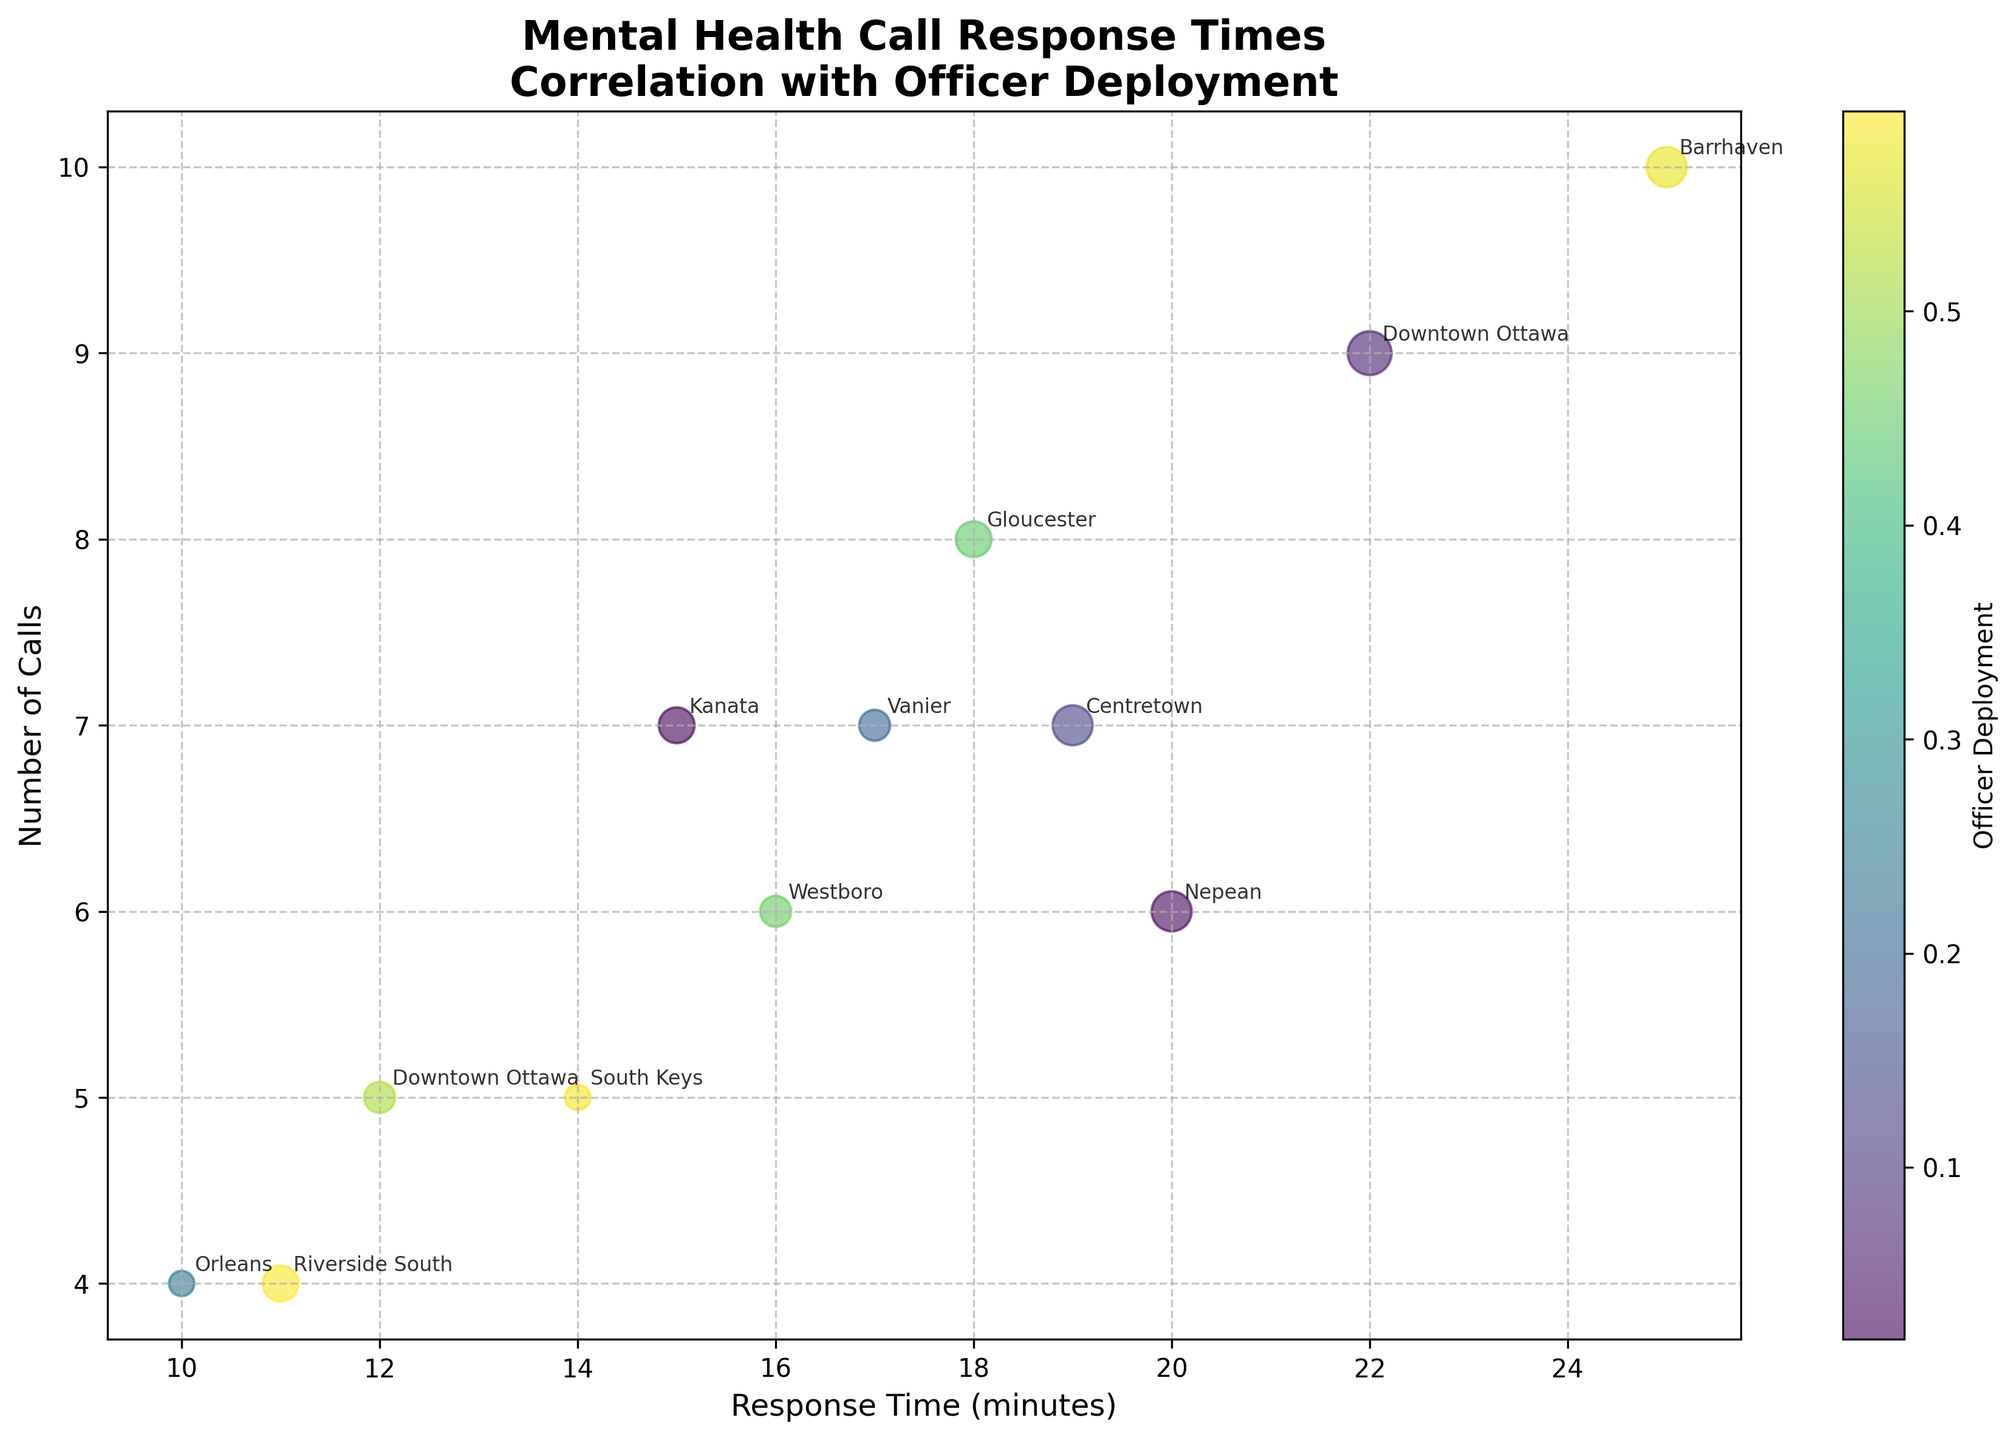what is the title of the figure? The title of the figure is located at the top. It reads "Mental Health Call Response Times\nCorrelation with Officer Deployment."
Answer: Mental Health Call Response Times Correlation with Officer Deployment Which location had the highest response time and what was it? To find the highest response time, look at the x-axis values. Barrhaven, with the data point at 25 minutes, has the highest response time.
Answer: Barrhaven, 25 minutes How many calls were there on February 15, 2023? Locate February 15, 2023 in the plot and check the corresponding y-axis value. The number of calls is 7.
Answer: 7 Which two incident locations had the exact same number of calls, and what was the number? Identify points with the same y-axis values. Downtown Ottawa and South Keys both had 5 calls.
Answer: Downtown Ottawa and South Keys, 5 How many officers were deployed on November 21, 2023? Find the bubble associated with November 21, 2023, and identify its size. It indicates that 4 officers were deployed.
Answer: 4 What is the average response time? Sum all the response times and divide them by the number of data points: (12 + 15 + 20 + 10 + 25 + 18 + 22 + 16 + 14 + 19 + 11 + 17) / 12 = 199 / 12 ≈ 16.58 minutes.
Answer: 16.58 minutes Is there a trend between the number of calls and the officers deployed? Check the relationship between the y-axis (number of calls) and bubble sizes (officers deployed). Larger bubbles generally appear with higher y-values, indicating a positive correlation.
Answer: Yes, there's a positive correlation Which location had the shortest response time? Locate the smallest x-value on the plot. Orleans has the shortest response time of 10 minutes.
Answer: Orleans, 10 minutes Compare response times and officers deployed for March 10 and October 19, 2023. Locate March 10 and October 19 on the x-axis. March 10 has a response time of 20 minutes and 5 officers, while October 19 has 19 minutes and also 5 officers deployed.
Answer: March 10: 20 minutes, 5 officers; October 19: 19 minutes, 5 officers What is the average number of officers deployed? (3 + 4 + 5 + 2 + 5 + 4 + 6 + 3 + 2 + 5 + 4 + 3) / 12 = 46 / 12 ≈ 3.83 officers.
Answer: 3.83 officers 